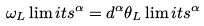<formula> <loc_0><loc_0><loc_500><loc_500>\omega _ { L } \lim i t s ^ { \alpha } = d ^ { \alpha } \theta _ { L } \lim i t s ^ { \alpha }</formula> 